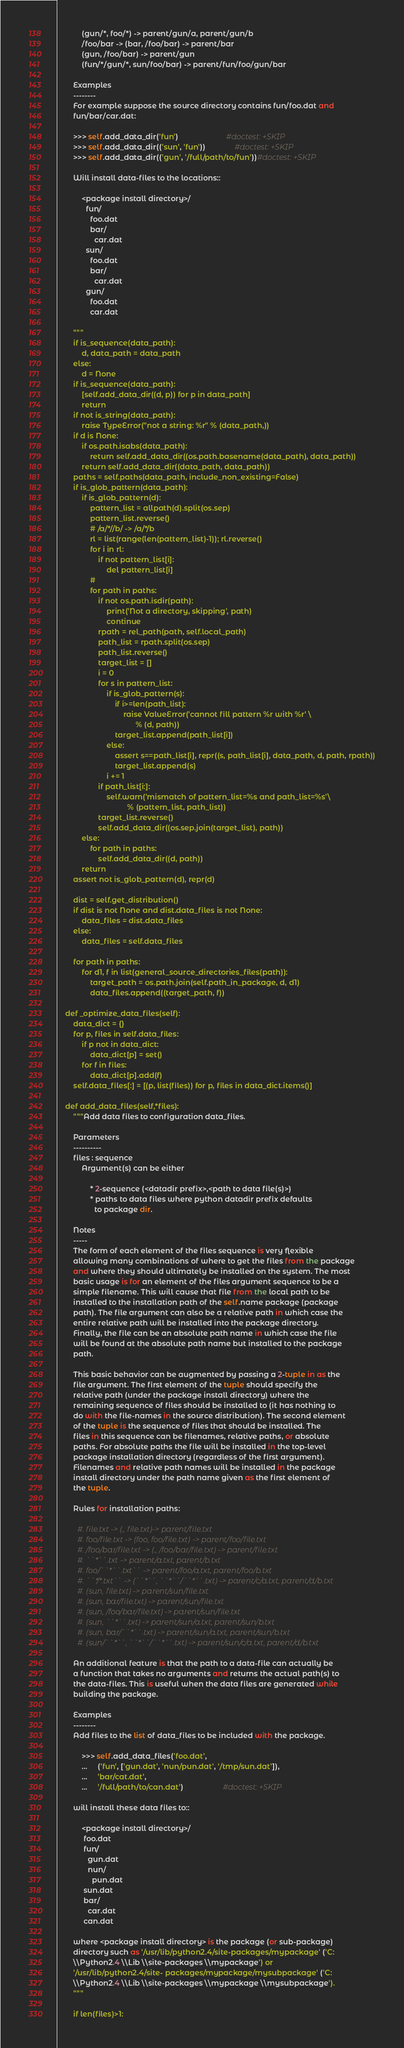<code> <loc_0><loc_0><loc_500><loc_500><_Python_>            (gun/*, foo/*) -> parent/gun/a, parent/gun/b
            /foo/bar -> (bar, /foo/bar) -> parent/bar
            (gun, /foo/bar) -> parent/gun
            (fun/*/gun/*, sun/foo/bar) -> parent/fun/foo/gun/bar

        Examples
        --------
        For example suppose the source directory contains fun/foo.dat and
        fun/bar/car.dat:

        >>> self.add_data_dir('fun')                       #doctest: +SKIP
        >>> self.add_data_dir(('sun', 'fun'))              #doctest: +SKIP
        >>> self.add_data_dir(('gun', '/full/path/to/fun'))#doctest: +SKIP

        Will install data-files to the locations::

            <package install directory>/
              fun/
                foo.dat
                bar/
                  car.dat
              sun/
                foo.dat
                bar/
                  car.dat
              gun/
                foo.dat
                car.dat

        """
        if is_sequence(data_path):
            d, data_path = data_path
        else:
            d = None
        if is_sequence(data_path):
            [self.add_data_dir((d, p)) for p in data_path]
            return
        if not is_string(data_path):
            raise TypeError("not a string: %r" % (data_path,))
        if d is None:
            if os.path.isabs(data_path):
                return self.add_data_dir((os.path.basename(data_path), data_path))
            return self.add_data_dir((data_path, data_path))
        paths = self.paths(data_path, include_non_existing=False)
        if is_glob_pattern(data_path):
            if is_glob_pattern(d):
                pattern_list = allpath(d).split(os.sep)
                pattern_list.reverse()
                # /a/*//b/ -> /a/*/b
                rl = list(range(len(pattern_list)-1)); rl.reverse()
                for i in rl:
                    if not pattern_list[i]:
                        del pattern_list[i]
                #
                for path in paths:
                    if not os.path.isdir(path):
                        print('Not a directory, skipping', path)
                        continue
                    rpath = rel_path(path, self.local_path)
                    path_list = rpath.split(os.sep)
                    path_list.reverse()
                    target_list = []
                    i = 0
                    for s in pattern_list:
                        if is_glob_pattern(s):
                            if i>=len(path_list):
                                raise ValueError('cannot fill pattern %r with %r' \
                                      % (d, path))
                            target_list.append(path_list[i])
                        else:
                            assert s==path_list[i], repr((s, path_list[i], data_path, d, path, rpath))
                            target_list.append(s)
                        i += 1
                    if path_list[i:]:
                        self.warn('mismatch of pattern_list=%s and path_list=%s'\
                                  % (pattern_list, path_list))
                    target_list.reverse()
                    self.add_data_dir((os.sep.join(target_list), path))
            else:
                for path in paths:
                    self.add_data_dir((d, path))
            return
        assert not is_glob_pattern(d), repr(d)

        dist = self.get_distribution()
        if dist is not None and dist.data_files is not None:
            data_files = dist.data_files
        else:
            data_files = self.data_files

        for path in paths:
            for d1, f in list(general_source_directories_files(path)):
                target_path = os.path.join(self.path_in_package, d, d1)
                data_files.append((target_path, f))

    def _optimize_data_files(self):
        data_dict = {}
        for p, files in self.data_files:
            if p not in data_dict:
                data_dict[p] = set()
            for f in files:
                data_dict[p].add(f)
        self.data_files[:] = [(p, list(files)) for p, files in data_dict.items()]

    def add_data_files(self,*files):
        """Add data files to configuration data_files.

        Parameters
        ----------
        files : sequence
            Argument(s) can be either

                * 2-sequence (<datadir prefix>,<path to data file(s)>)
                * paths to data files where python datadir prefix defaults
                  to package dir.

        Notes
        -----
        The form of each element of the files sequence is very flexible
        allowing many combinations of where to get the files from the package
        and where they should ultimately be installed on the system. The most
        basic usage is for an element of the files argument sequence to be a
        simple filename. This will cause that file from the local path to be
        installed to the installation path of the self.name package (package
        path). The file argument can also be a relative path in which case the
        entire relative path will be installed into the package directory.
        Finally, the file can be an absolute path name in which case the file
        will be found at the absolute path name but installed to the package
        path.

        This basic behavior can be augmented by passing a 2-tuple in as the
        file argument. The first element of the tuple should specify the
        relative path (under the package install directory) where the
        remaining sequence of files should be installed to (it has nothing to
        do with the file-names in the source distribution). The second element
        of the tuple is the sequence of files that should be installed. The
        files in this sequence can be filenames, relative paths, or absolute
        paths. For absolute paths the file will be installed in the top-level
        package installation directory (regardless of the first argument).
        Filenames and relative path names will be installed in the package
        install directory under the path name given as the first element of
        the tuple.

        Rules for installation paths:

          #. file.txt -> (., file.txt)-> parent/file.txt
          #. foo/file.txt -> (foo, foo/file.txt) -> parent/foo/file.txt
          #. /foo/bar/file.txt -> (., /foo/bar/file.txt) -> parent/file.txt
          #. ``*``.txt -> parent/a.txt, parent/b.txt
          #. foo/``*``.txt`` -> parent/foo/a.txt, parent/foo/b.txt
          #. ``*/*.txt`` -> (``*``, ``*``/``*``.txt) -> parent/c/a.txt, parent/d/b.txt
          #. (sun, file.txt) -> parent/sun/file.txt
          #. (sun, bar/file.txt) -> parent/sun/file.txt
          #. (sun, /foo/bar/file.txt) -> parent/sun/file.txt
          #. (sun, ``*``.txt) -> parent/sun/a.txt, parent/sun/b.txt
          #. (sun, bar/``*``.txt) -> parent/sun/a.txt, parent/sun/b.txt
          #. (sun/``*``, ``*``/``*``.txt) -> parent/sun/c/a.txt, parent/d/b.txt

        An additional feature is that the path to a data-file can actually be
        a function that takes no arguments and returns the actual path(s) to
        the data-files. This is useful when the data files are generated while
        building the package.

        Examples
        --------
        Add files to the list of data_files to be included with the package.

            >>> self.add_data_files('foo.dat',
            ...     ('fun', ['gun.dat', 'nun/pun.dat', '/tmp/sun.dat']),
            ...     'bar/cat.dat',
            ...     '/full/path/to/can.dat')                   #doctest: +SKIP

        will install these data files to::

            <package install directory>/
             foo.dat
             fun/
               gun.dat
               nun/
                 pun.dat
             sun.dat
             bar/
               car.dat
             can.dat

        where <package install directory> is the package (or sub-package)
        directory such as '/usr/lib/python2.4/site-packages/mypackage' ('C:
        \\Python2.4 \\Lib \\site-packages \\mypackage') or
        '/usr/lib/python2.4/site- packages/mypackage/mysubpackage' ('C:
        \\Python2.4 \\Lib \\site-packages \\mypackage \\mysubpackage').
        """

        if len(files)>1:</code> 